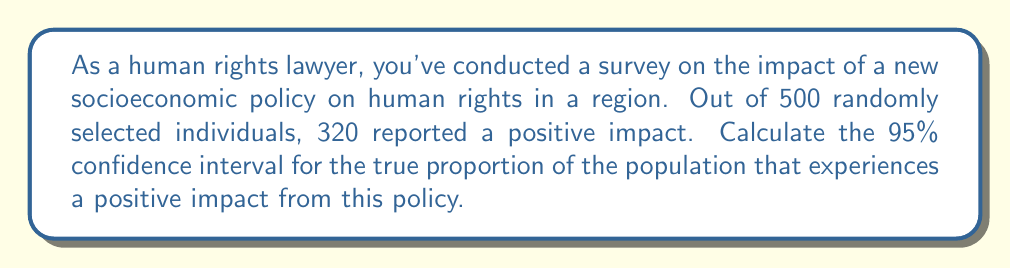What is the answer to this math problem? Let's approach this step-by-step:

1) First, we need to calculate the sample proportion:
   $\hat{p} = \frac{320}{500} = 0.64$

2) The formula for the confidence interval is:
   $$\hat{p} \pm z_{\alpha/2} \sqrt{\frac{\hat{p}(1-\hat{p})}{n}}$$
   where $z_{\alpha/2}$ is the critical value for the desired confidence level.

3) For a 95% confidence interval, $z_{\alpha/2} = 1.96$

4) Now, let's calculate the standard error:
   $$SE = \sqrt{\frac{\hat{p}(1-\hat{p})}{n}} = \sqrt{\frac{0.64(1-0.64)}{500}} = 0.0214$$

5) The margin of error is:
   $$ME = z_{\alpha/2} \cdot SE = 1.96 \cdot 0.0214 = 0.042$$

6) Therefore, the confidence interval is:
   $$0.64 \pm 0.042$$

7) This gives us the interval:
   $$(0.64 - 0.042, 0.64 + 0.042) = (0.598, 0.682)$$

Thus, we can be 95% confident that the true proportion of the population experiencing a positive impact from the policy is between 0.598 and 0.682, or 59.8% to 68.2%.
Answer: (0.598, 0.682) 